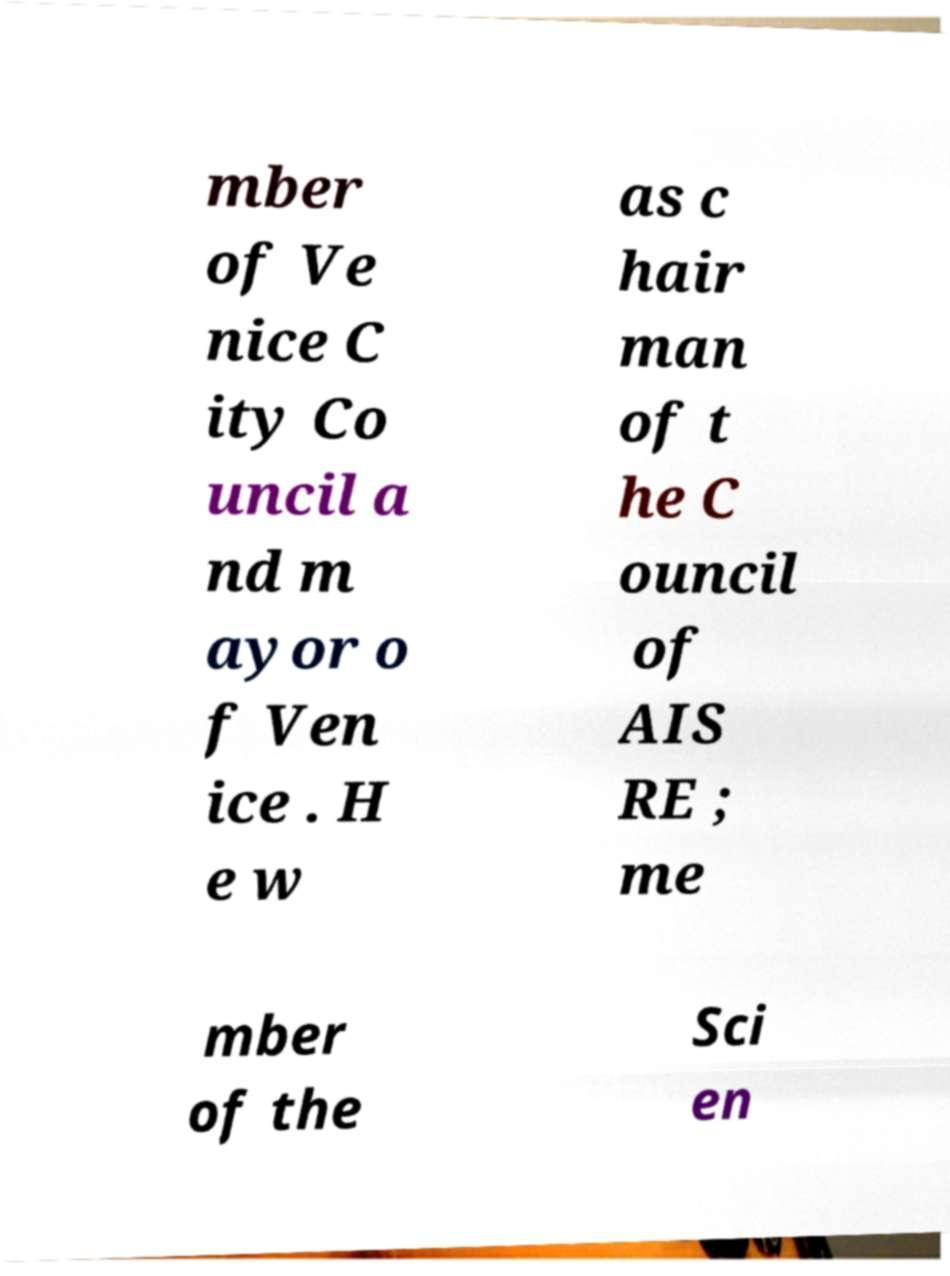Could you assist in decoding the text presented in this image and type it out clearly? mber of Ve nice C ity Co uncil a nd m ayor o f Ven ice . H e w as c hair man of t he C ouncil of AIS RE ; me mber of the Sci en 